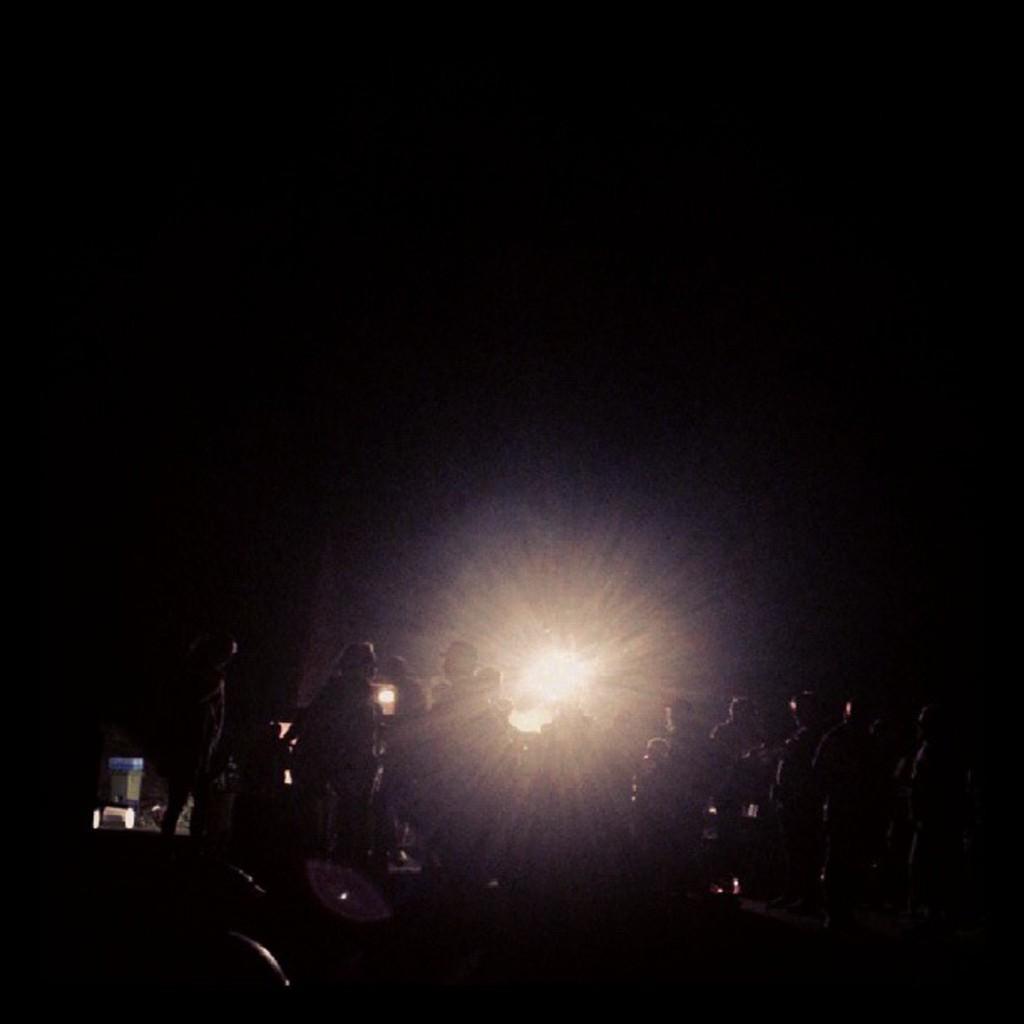Could you give a brief overview of what you see in this image? The image is dark and there are a group of people gathered in a place and behind them there is a huge spotlight. 